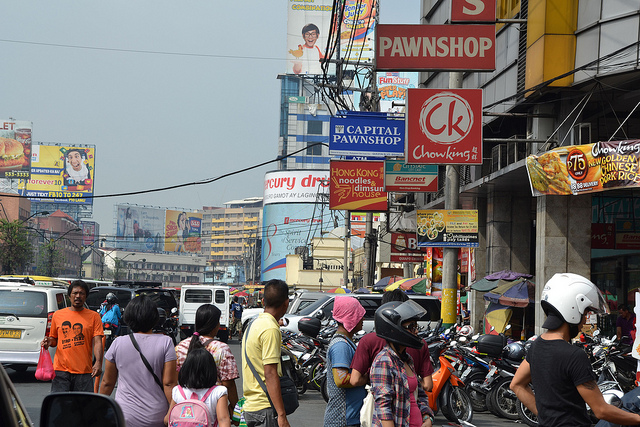Please transcribe the text in this image. CAPITAL PAWNSHOP Chowking HONG KONG noobles dimsun F810 TO 267 ET CURY B dimsun RICE CHINESE GOLDEN Chowking P75 CK PAWNSHOP 